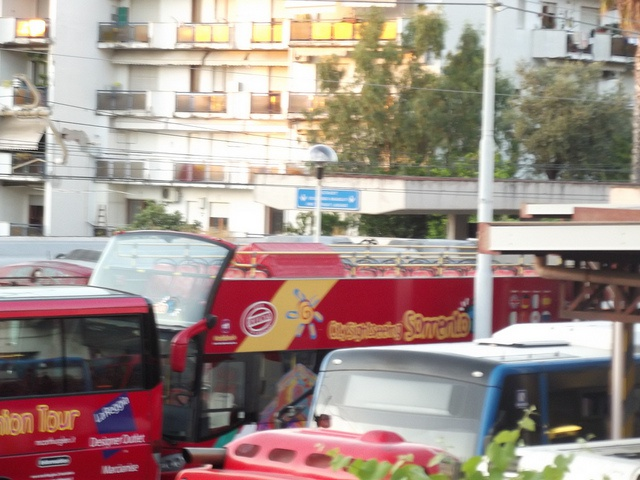Describe the objects in this image and their specific colors. I can see bus in white, brown, lightgray, and black tones, bus in white, lightgray, black, darkgray, and gray tones, bus in white, black, brown, gray, and maroon tones, and bus in white, lightgray, and darkgray tones in this image. 